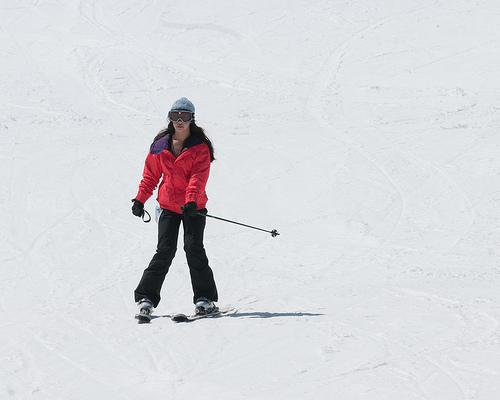Question: who is skiing?
Choices:
A. The man.
B. The woman.
C. The child.
D. The teen.
Answer with the letter. Answer: B Question: what is on the ground?
Choices:
A. Rain.
B. Dirt.
C. Snow.
D. Litter.
Answer with the letter. Answer: C Question: where was the picture taken?
Choices:
A. Ski slope.
B. In the Mountains.
C. On the yacht.
D. By the Bay.
Answer with the letter. Answer: A 